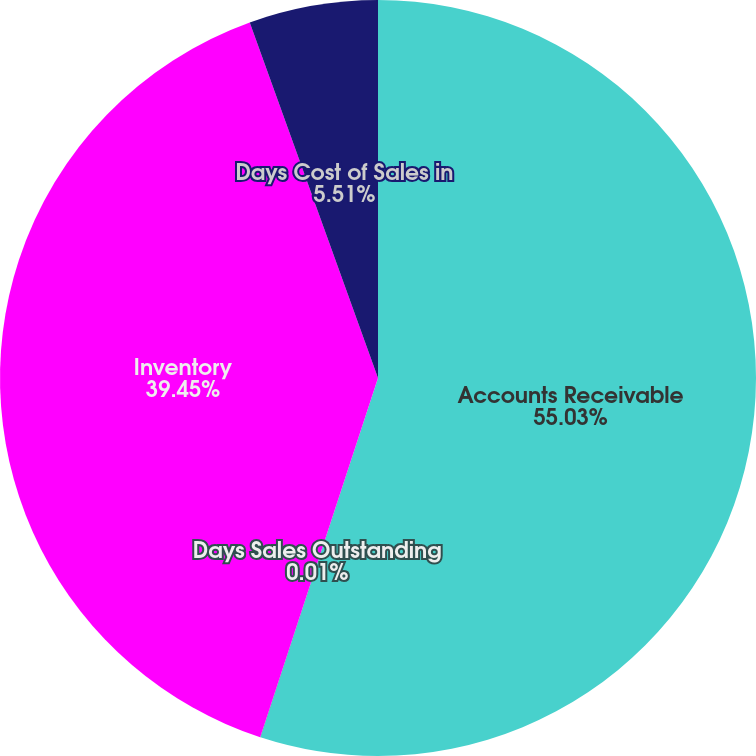Convert chart. <chart><loc_0><loc_0><loc_500><loc_500><pie_chart><fcel>Accounts Receivable<fcel>Days Sales Outstanding<fcel>Inventory<fcel>Days Cost of Sales in<nl><fcel>55.04%<fcel>0.01%<fcel>39.45%<fcel>5.51%<nl></chart> 